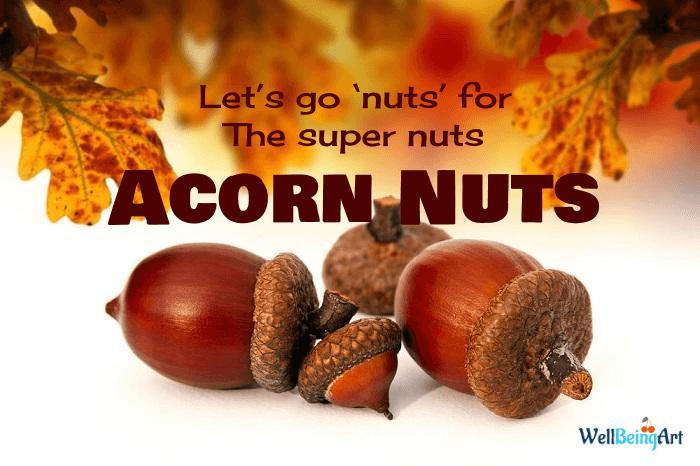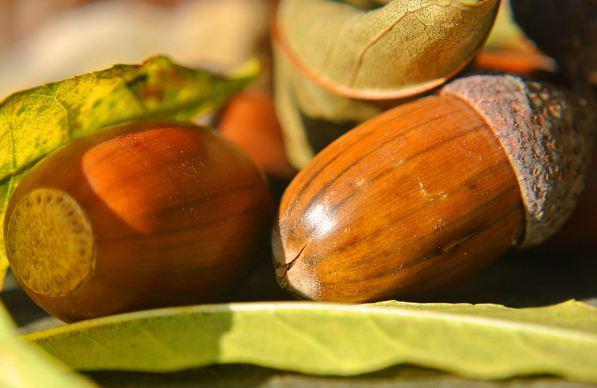The first image is the image on the left, the second image is the image on the right. Given the left and right images, does the statement "The right image shows no more than three acorns on an autumn leaf, and the left image features acorn shapes that aren't really acorns." hold true? Answer yes or no. No. The first image is the image on the left, the second image is the image on the right. Given the left and right images, does the statement "One of the images is food made to look like acorns." hold true? Answer yes or no. No. 